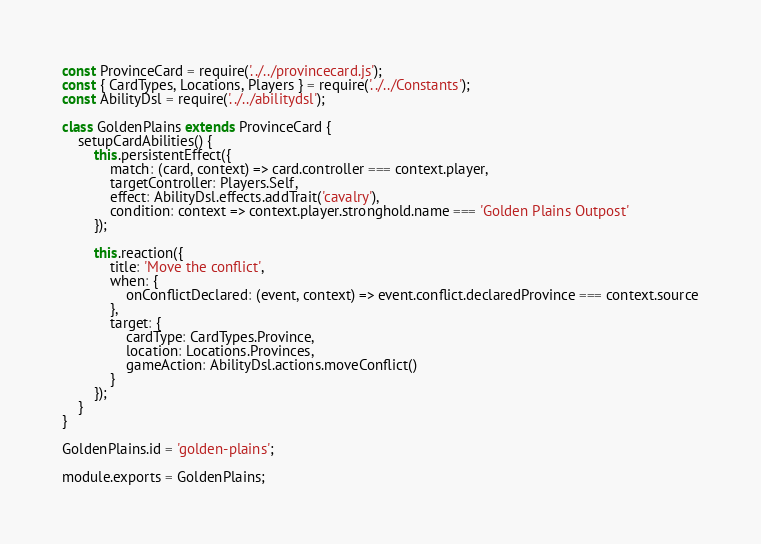Convert code to text. <code><loc_0><loc_0><loc_500><loc_500><_JavaScript_>const ProvinceCard = require('../../provincecard.js');
const { CardTypes, Locations, Players } = require('../../Constants');
const AbilityDsl = require('../../abilitydsl');

class GoldenPlains extends ProvinceCard {
    setupCardAbilities() {
        this.persistentEffect({
            match: (card, context) => card.controller === context.player,
            targetController: Players.Self,
            effect: AbilityDsl.effects.addTrait('cavalry'),
            condition: context => context.player.stronghold.name === 'Golden Plains Outpost'
        });

        this.reaction({
            title: 'Move the conflict',
            when: {
                onConflictDeclared: (event, context) => event.conflict.declaredProvince === context.source
            },
            target: {
                cardType: CardTypes.Province,
                location: Locations.Provinces,
                gameAction: AbilityDsl.actions.moveConflict()
            }
        });
    }
}

GoldenPlains.id = 'golden-plains';

module.exports = GoldenPlains;
</code> 